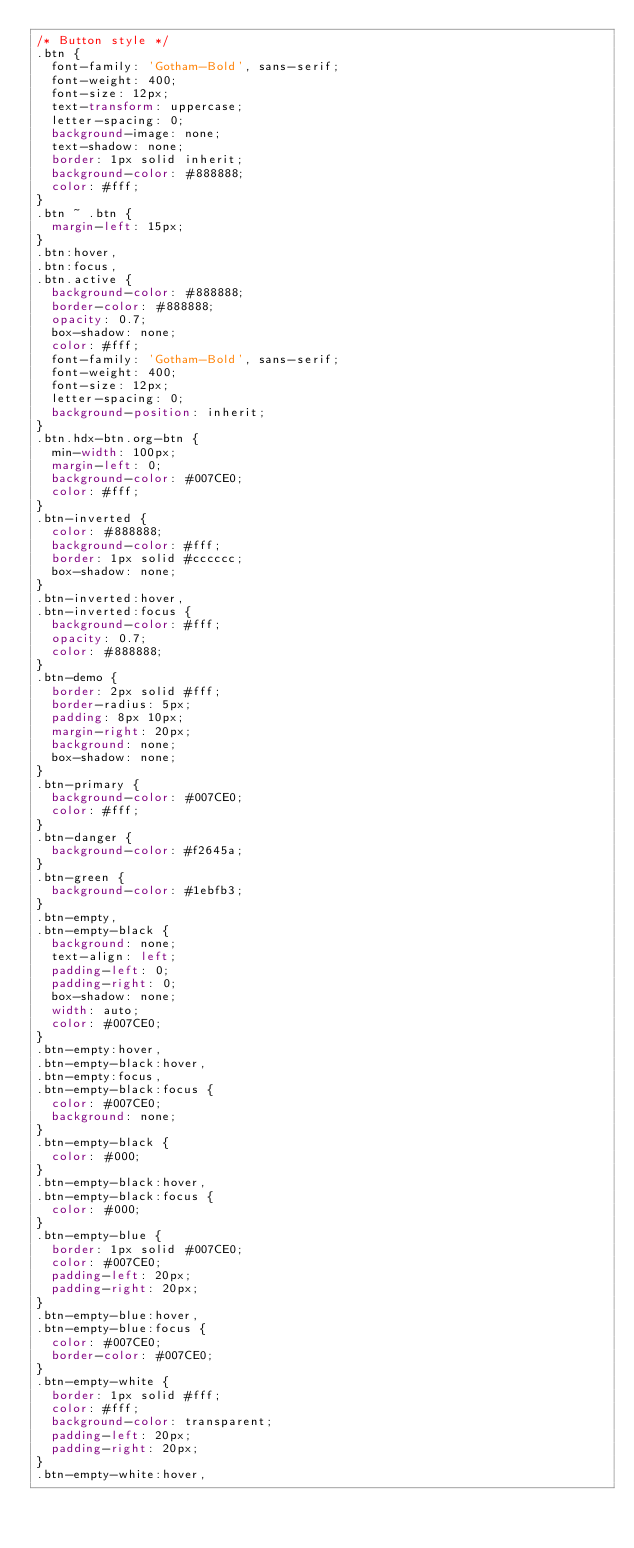Convert code to text. <code><loc_0><loc_0><loc_500><loc_500><_CSS_>/* Button style */
.btn {
  font-family: 'Gotham-Bold', sans-serif;
  font-weight: 400;
  font-size: 12px;
  text-transform: uppercase;
  letter-spacing: 0;
  background-image: none;
  text-shadow: none;
  border: 1px solid inherit;
  background-color: #888888;
  color: #fff;
}
.btn ~ .btn {
  margin-left: 15px;
}
.btn:hover,
.btn:focus,
.btn.active {
  background-color: #888888;
  border-color: #888888;
  opacity: 0.7;
  box-shadow: none;
  color: #fff;
  font-family: 'Gotham-Bold', sans-serif;
  font-weight: 400;
  font-size: 12px;
  letter-spacing: 0;
  background-position: inherit;
}
.btn.hdx-btn.org-btn {
  min-width: 100px;
  margin-left: 0;
  background-color: #007CE0;
  color: #fff;
}
.btn-inverted {
  color: #888888;
  background-color: #fff;
  border: 1px solid #cccccc;
  box-shadow: none;
}
.btn-inverted:hover,
.btn-inverted:focus {
  background-color: #fff;
  opacity: 0.7;
  color: #888888;
}
.btn-demo {
  border: 2px solid #fff;
  border-radius: 5px;
  padding: 8px 10px;
  margin-right: 20px;
  background: none;
  box-shadow: none;
}
.btn-primary {
  background-color: #007CE0;
  color: #fff;
}
.btn-danger {
  background-color: #f2645a;
}
.btn-green {
  background-color: #1ebfb3;
}
.btn-empty,
.btn-empty-black {
  background: none;
  text-align: left;
  padding-left: 0;
  padding-right: 0;
  box-shadow: none;
  width: auto;
  color: #007CE0;
}
.btn-empty:hover,
.btn-empty-black:hover,
.btn-empty:focus,
.btn-empty-black:focus {
  color: #007CE0;
  background: none;
}
.btn-empty-black {
  color: #000;
}
.btn-empty-black:hover,
.btn-empty-black:focus {
  color: #000;
}
.btn-empty-blue {
  border: 1px solid #007CE0;
  color: #007CE0;
  padding-left: 20px;
  padding-right: 20px;
}
.btn-empty-blue:hover,
.btn-empty-blue:focus {
  color: #007CE0;
  border-color: #007CE0;
}
.btn-empty-white {
  border: 1px solid #fff;
  color: #fff;
  background-color: transparent;
  padding-left: 20px;
  padding-right: 20px;
}
.btn-empty-white:hover,</code> 